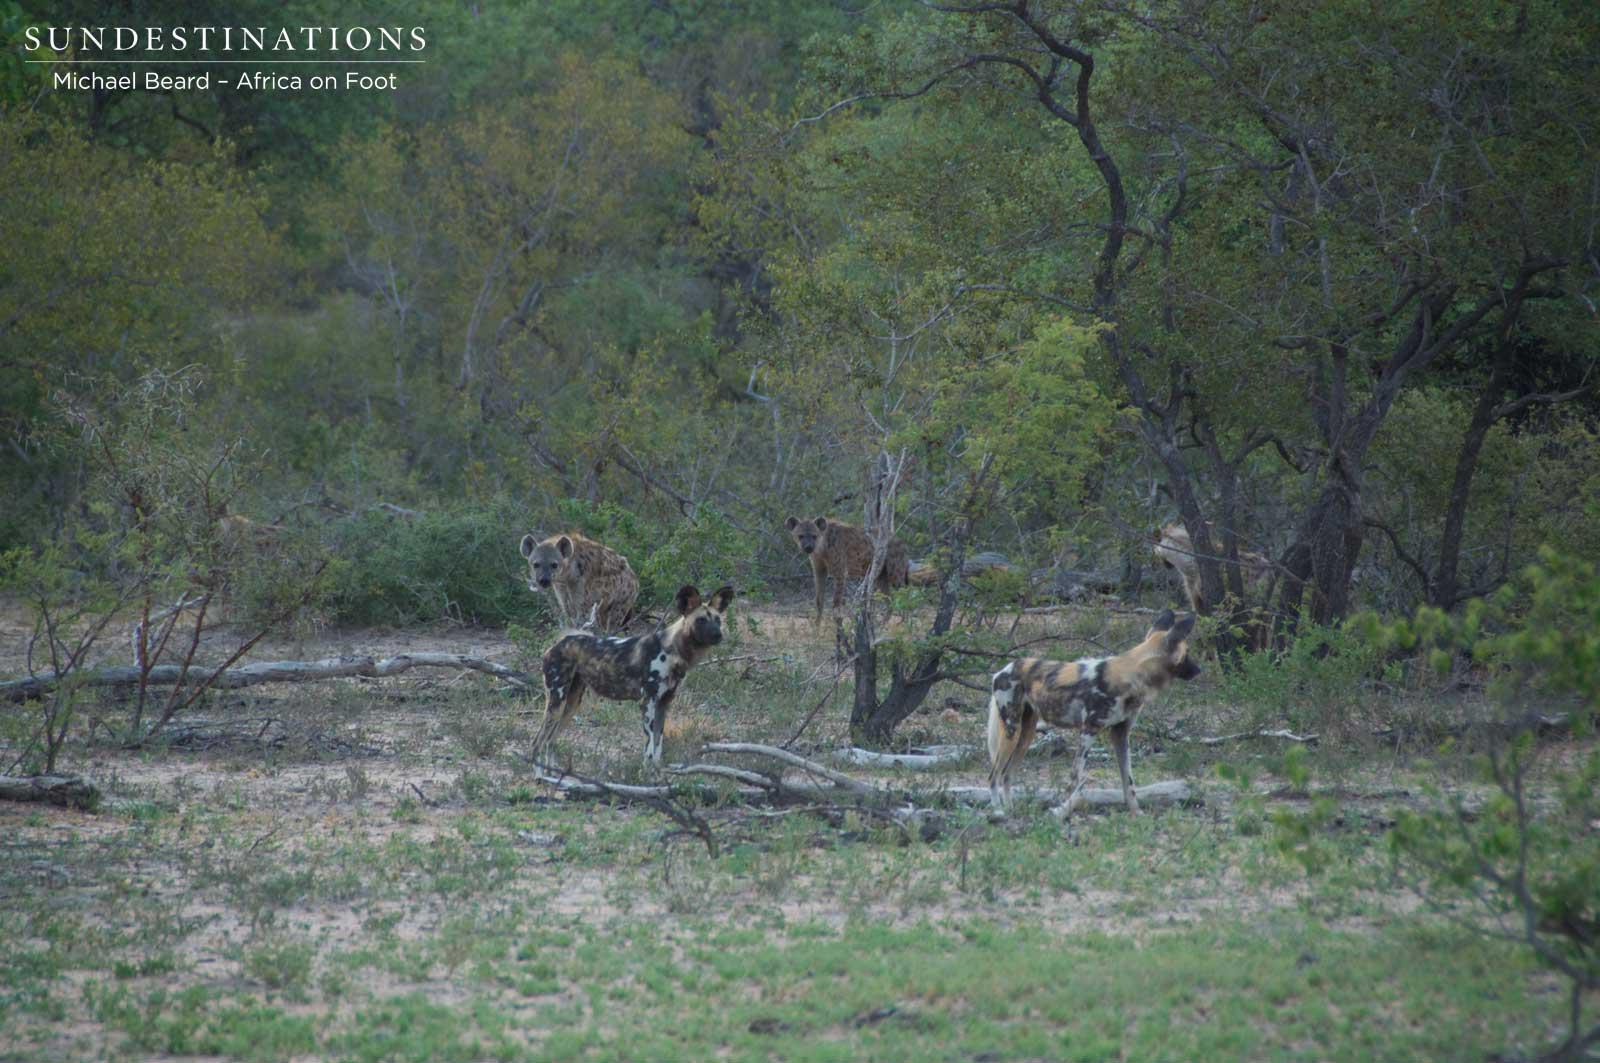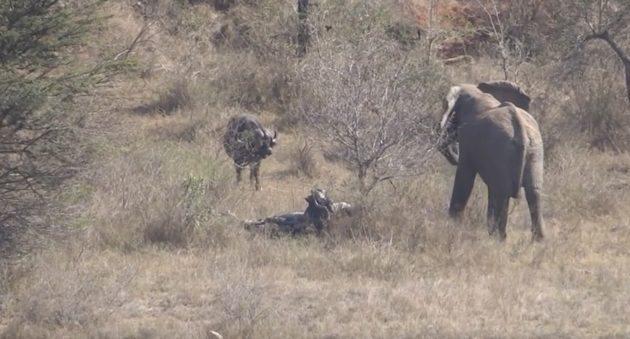The first image is the image on the left, the second image is the image on the right. Considering the images on both sides, is "The left image shows at least one rear-facing hyena standing in front of two larger standing animals with horns." valid? Answer yes or no. No. 